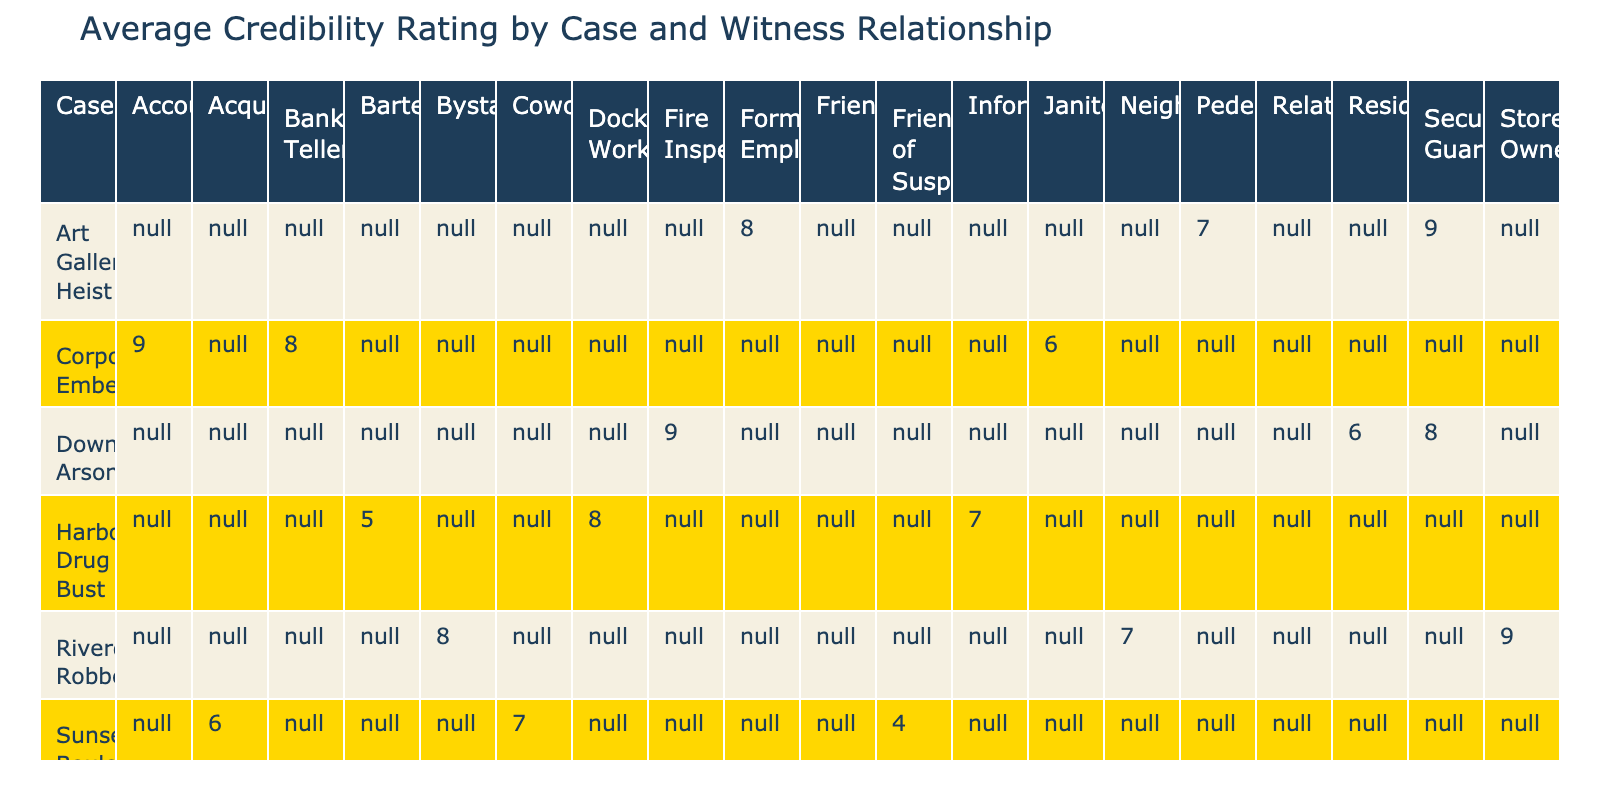What is the average credibility rating for witnesses who are bystanders in the Riverdale Robbery case? There are two witnesses with the relationship of bystander in the Riverdale Robbery case: John Smith and Emma Johnson. Their credibility ratings are 8 and 7 respectively. The average is calculated as (8 + 7) / 2 = 7.5.
Answer: 7.5 Which case has the highest average credibility rating among witness relationships? By inspecting the table, I find that the Westside Kidnapping has a witness credibility rating of 9 (Sophie Anderson), 6 (William Turner), and 7 (Grace Miller). The average is (9 + 6 + 7) / 3 = 7.33. Meanwhile, the Corporate Embezzlement case has witnesses with ratings of 9, 8, and 6, averaging 7.67. Thus, Corporate Embezzlement has the highest average rating.
Answer: Corporate Embezzlement Did any witness relationships of Security Guards have a lower credibility rating than that of Coworkers in the Sunset Boulevard Murder case? In the table, the only Security Guard is David Lee in Downtown Arson with a rating of 8. For the Sunset Boulevard Murder, the Coworker, Lisa Thompson, has a credibility rating of 7. Since 8 is greater than 7, this statement is false.
Answer: No Which witness provided the highest credibility rating and what was the corresponding case? Upon reviewing the table, I see the witness with the highest rating of 9 is Michael Brown from the Riverdale Robbery case and also Thomas Green in the Art Gallery Heist. Therefore, there are two cases with this highest rating of 9.
Answer: Riverdale Robbery & Art Gallery Heist What is the combined credibility rating of all witnesses in the Harbor Drug Bust case? In the Harbor Drug Bust case, the witnesses are Maria Rodriguez (rating 7), James Taylor (rating 8), and Emily Foster (rating 5). The combined sum is 7 + 8 + 5 = 20.
Answer: 20 